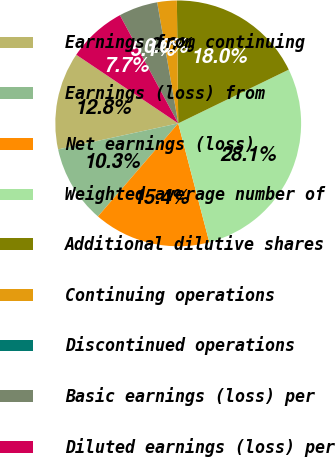<chart> <loc_0><loc_0><loc_500><loc_500><pie_chart><fcel>Earnings from continuing<fcel>Earnings (loss) from<fcel>Net earnings (loss)<fcel>Weighted average number of<fcel>Additional dilutive shares<fcel>Continuing operations<fcel>Discontinued operations<fcel>Basic earnings (loss) per<fcel>Diluted earnings (loss) per<nl><fcel>12.83%<fcel>10.27%<fcel>15.4%<fcel>28.13%<fcel>17.97%<fcel>2.57%<fcel>0.0%<fcel>5.13%<fcel>7.7%<nl></chart> 